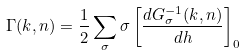Convert formula to latex. <formula><loc_0><loc_0><loc_500><loc_500>\Gamma ( { k } , n ) = \frac { 1 } { 2 } \sum _ { \sigma } \sigma \left [ \frac { d G _ { \sigma } ^ { - 1 } ( { k } , n ) } { d h } \right ] _ { 0 }</formula> 